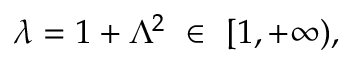Convert formula to latex. <formula><loc_0><loc_0><loc_500><loc_500>\lambda = 1 + \Lambda ^ { 2 } \ \in \ [ 1 , + \infty ) ,</formula> 